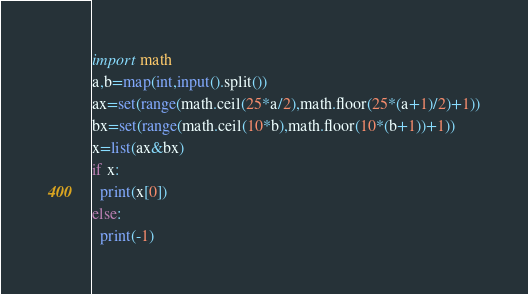<code> <loc_0><loc_0><loc_500><loc_500><_Python_>import math
a,b=map(int,input().split())
ax=set(range(math.ceil(25*a/2),math.floor(25*(a+1)/2)+1))
bx=set(range(math.ceil(10*b),math.floor(10*(b+1))+1))
x=list(ax&bx)
if x:
  print(x[0])
else:
  print(-1)</code> 